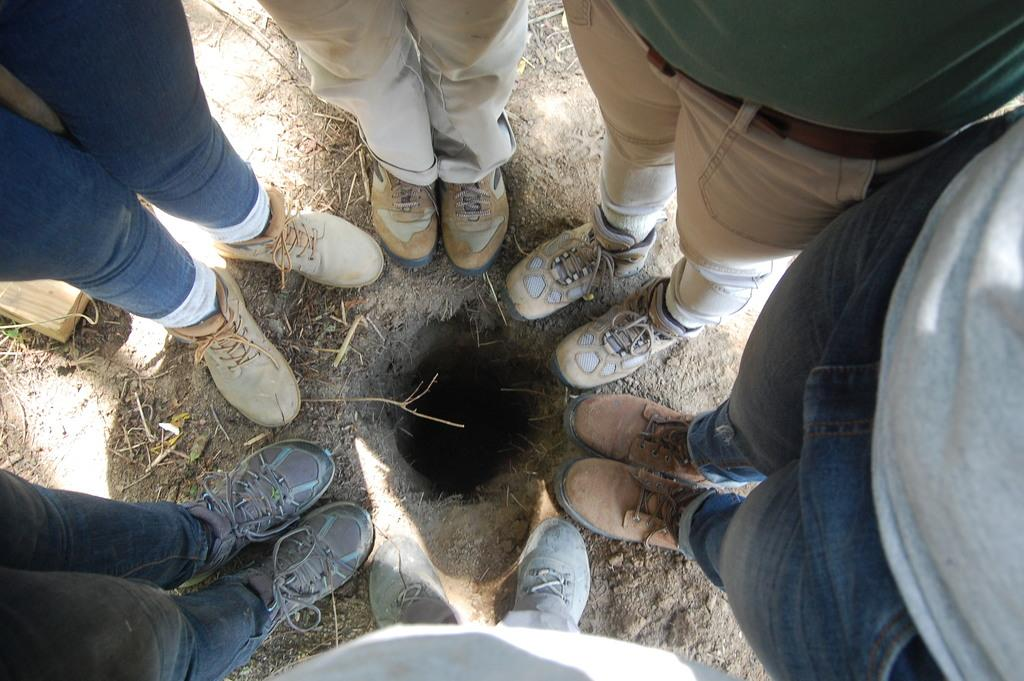What can be seen in the image involving human subjects? There are people standing in the image. What are the people wearing? The people are wearing clothes and shoes. Can you describe any specific features or objects in the image? There is a hole visible in the image. How many tickets can be seen in the hands of the people in the image? There is no mention of tickets in the image, so it cannot be determined how many, if any, tickets are present. 